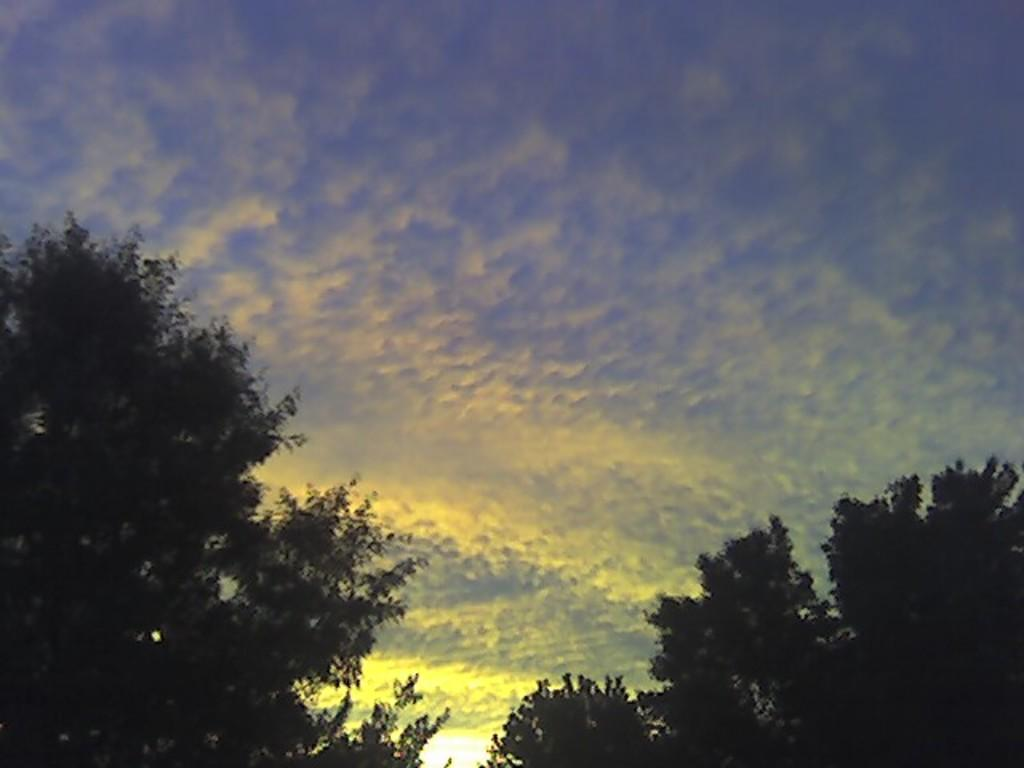What type of natural elements can be seen in the image? There are trees in the image. What part of the natural environment is visible in the image? The sky is visible in the image. Can you describe the time of day based on the image? The image may have been taken in the evening, as the sky appears to be darker. What type of shape can be seen on the desk in the image? There is no desk present in the image; it only features trees and the sky. 